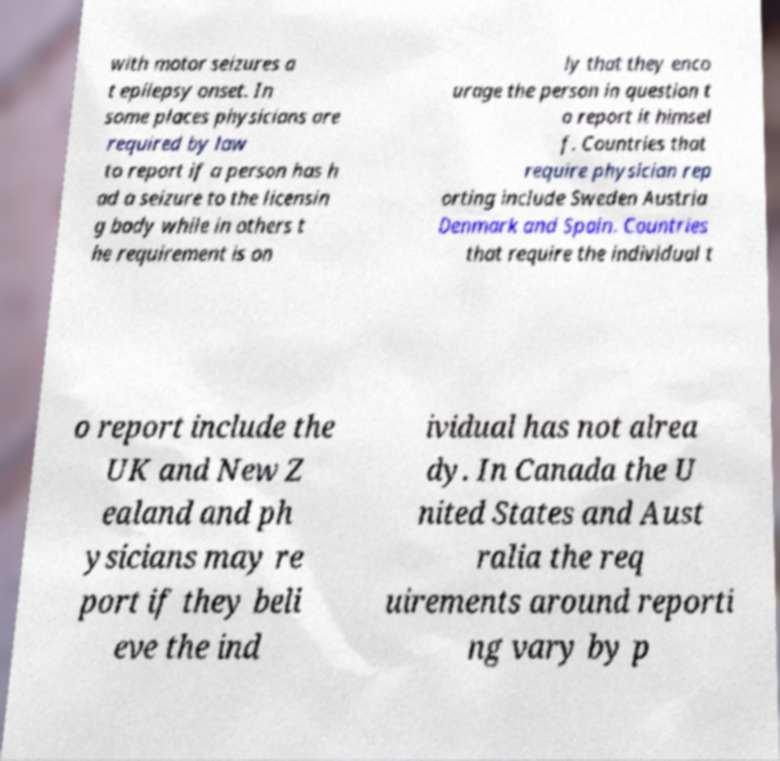Please read and relay the text visible in this image. What does it say? with motor seizures a t epilepsy onset. In some places physicians are required by law to report if a person has h ad a seizure to the licensin g body while in others t he requirement is on ly that they enco urage the person in question t o report it himsel f. Countries that require physician rep orting include Sweden Austria Denmark and Spain. Countries that require the individual t o report include the UK and New Z ealand and ph ysicians may re port if they beli eve the ind ividual has not alrea dy. In Canada the U nited States and Aust ralia the req uirements around reporti ng vary by p 